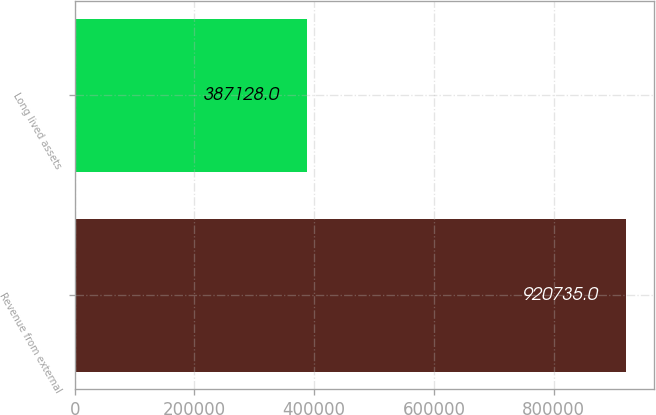Convert chart. <chart><loc_0><loc_0><loc_500><loc_500><bar_chart><fcel>Revenue from external<fcel>Long lived assets<nl><fcel>920735<fcel>387128<nl></chart> 